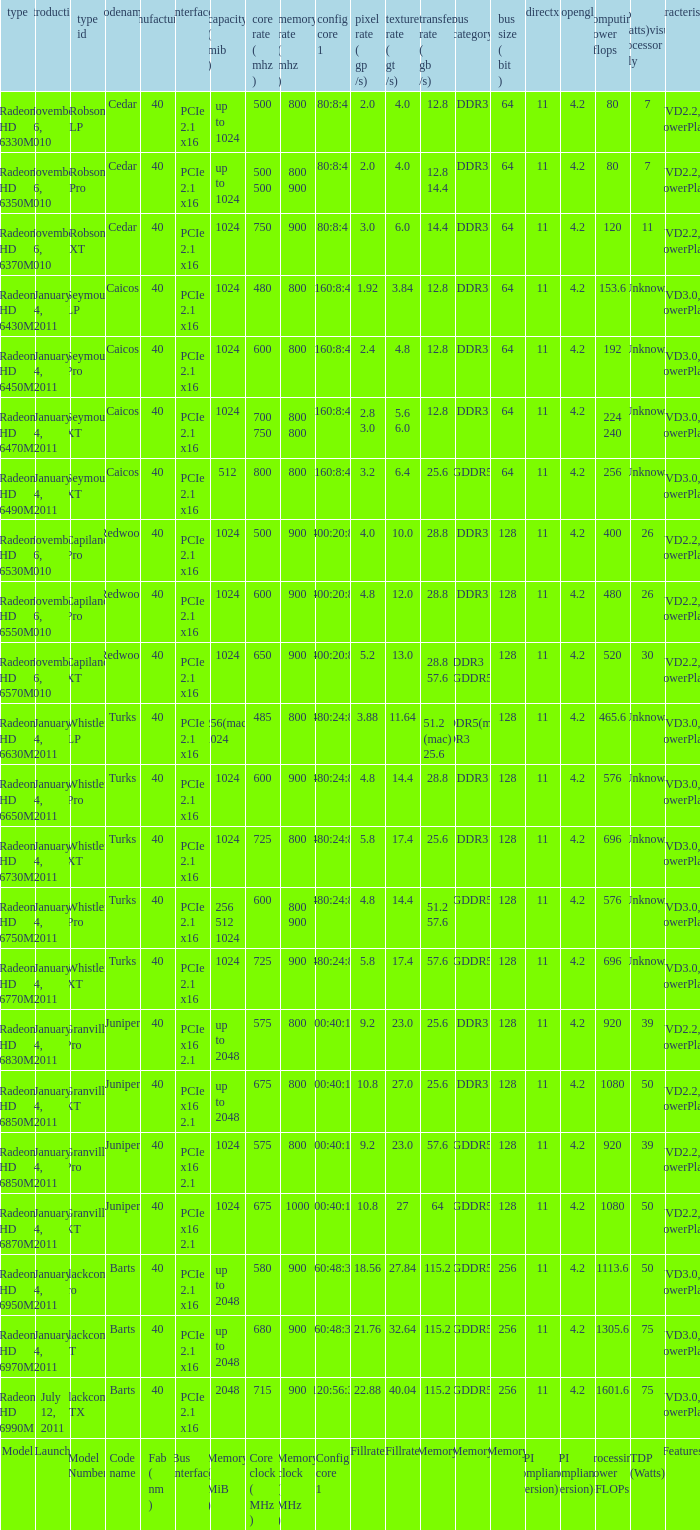What is the value for congi core 1 if the code name is Redwood and core clock(mhz) is 500? 400:20:8. 